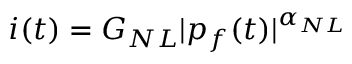<formula> <loc_0><loc_0><loc_500><loc_500>i ( t ) = G _ { N L } | p _ { f } ( t ) | ^ { \alpha _ { N L } }</formula> 